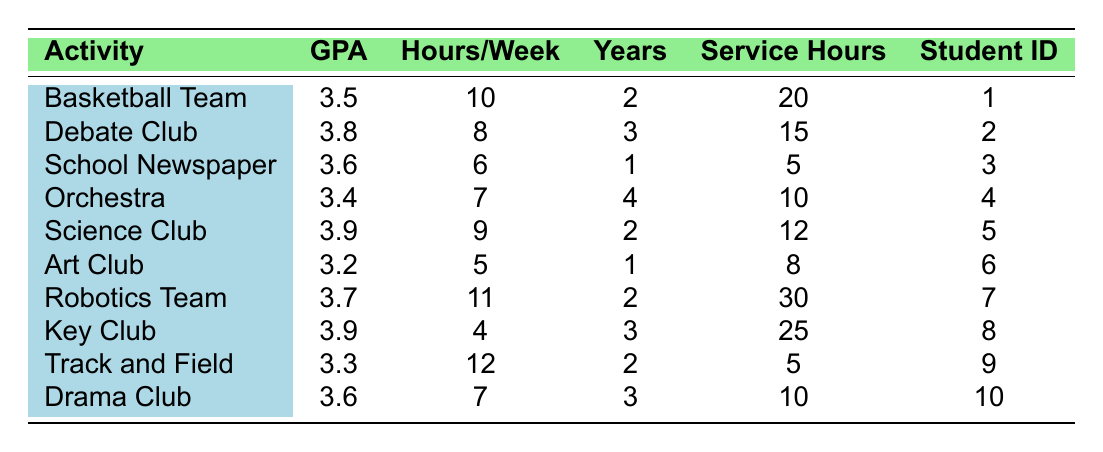What is the GPA of the student involved in the Orchestra? The table shows that the GPA for the student engaged in the Orchestra is listed under the GPA column next to Orchestra, which is 3.4.
Answer: 3.4 How many hours per week does the Robotics Team require? The table indicates that the Robotics Team has a value of 11 hours per week listed in the corresponding row.
Answer: 11 hours Which extracurricular activity has the highest GPA? By scanning through the GPA column, the highest GPA listed is 3.9, found under both the Science Club and Key Club activities.
Answer: Science Club and Key Club What is the average GPA of students participating in extracurricular activities? To find the average GPA, you sum the GPAs: (3.5 + 3.8 + 3.6 + 3.4 + 3.9 + 3.2 + 3.7 + 3.9 + 3.3 + 3.6) = 36.9. Then divide by the number of students: 36.9/10 = 3.69.
Answer: 3.69 True or False: The Art Club ranks the lowest GPA among the listed activities. Looking at the GPAs, the Art Club has a GPA of 3.2, which is lower than the others except for the Orchestra (3.4), confirming that it does rank lowest.
Answer: True What is the total number of community service hours for students in the Debate Club and Key Club? The community service hours for the Debate Club is 15 and for the Key Club is 25. Adding these gives: 15 + 25 = 40 hours.
Answer: 40 hours Which student was involved in the most years of participation? The table highlights that the student involved in the Orchestra has participated for 4 years, which is the highest among the listed students.
Answer: 4 years What are the participating years of the student who has the lowest community service hours? The student with the lowest community service hours is involved in the School Newspaper with only 5 hours, and thus they have participated for 1 year.
Answer: 1 year What is the difference in GPA between the student in Track and Field and the student in Science Club? The GPA for the student in Track and Field is 3.3 and for the Science Club it's 3.9. The difference is calculated as 3.9 - 3.3 = 0.6.
Answer: 0.6 Which extracurricular activity requires the least number of hours per week? By examining the hours per week column, the Art Club requires the least at 5 hours among the listed activities.
Answer: Art Club 